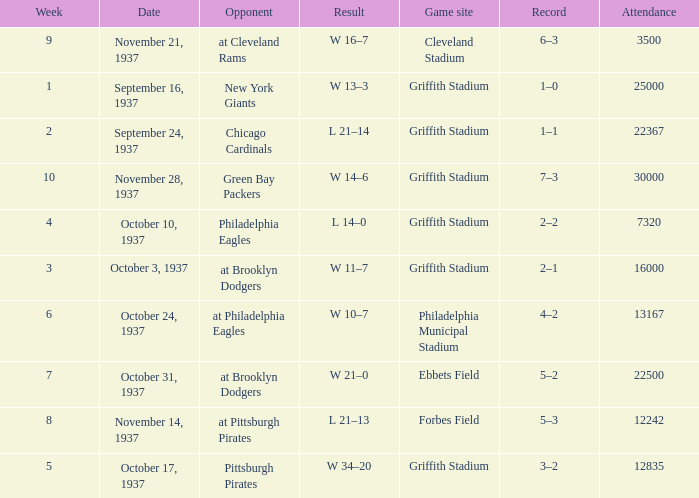On October 17, 1937 what was maximum number or attendants. 12835.0. 